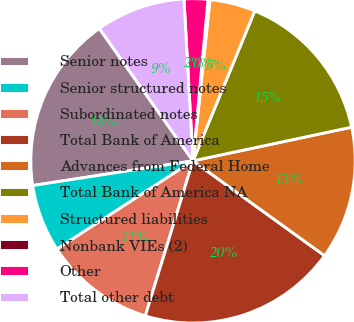Convert chart to OTSL. <chart><loc_0><loc_0><loc_500><loc_500><pie_chart><fcel>Senior notes<fcel>Senior structured notes<fcel>Subordinated notes<fcel>Total Bank of America<fcel>Advances from Federal Home<fcel>Total Bank of America NA<fcel>Structured liabilities<fcel>Nonbank VIEs (2)<fcel>Other<fcel>Total other debt<nl><fcel>17.63%<fcel>6.73%<fcel>11.09%<fcel>19.81%<fcel>13.27%<fcel>15.45%<fcel>4.55%<fcel>0.19%<fcel>2.37%<fcel>8.91%<nl></chart> 